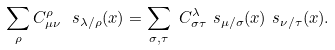<formula> <loc_0><loc_0><loc_500><loc_500>\sum _ { \rho } C ^ { \rho } _ { \mu \nu } \ s _ { \lambda / \rho } ( x ) & = \sum _ { \sigma , \tau } \ C ^ { \lambda } _ { \sigma \tau } \ s _ { \mu / \sigma } ( x ) \ s _ { \nu / \tau } ( x ) .</formula> 